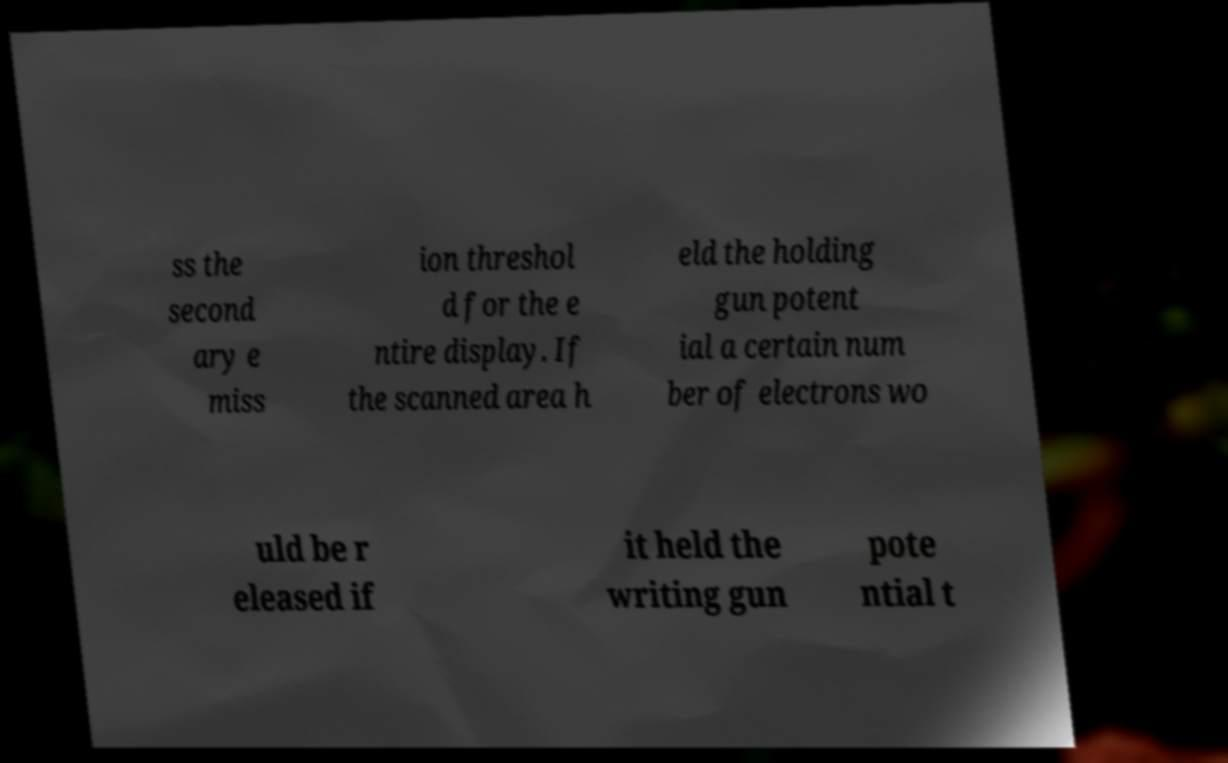Please identify and transcribe the text found in this image. ss the second ary e miss ion threshol d for the e ntire display. If the scanned area h eld the holding gun potent ial a certain num ber of electrons wo uld be r eleased if it held the writing gun pote ntial t 